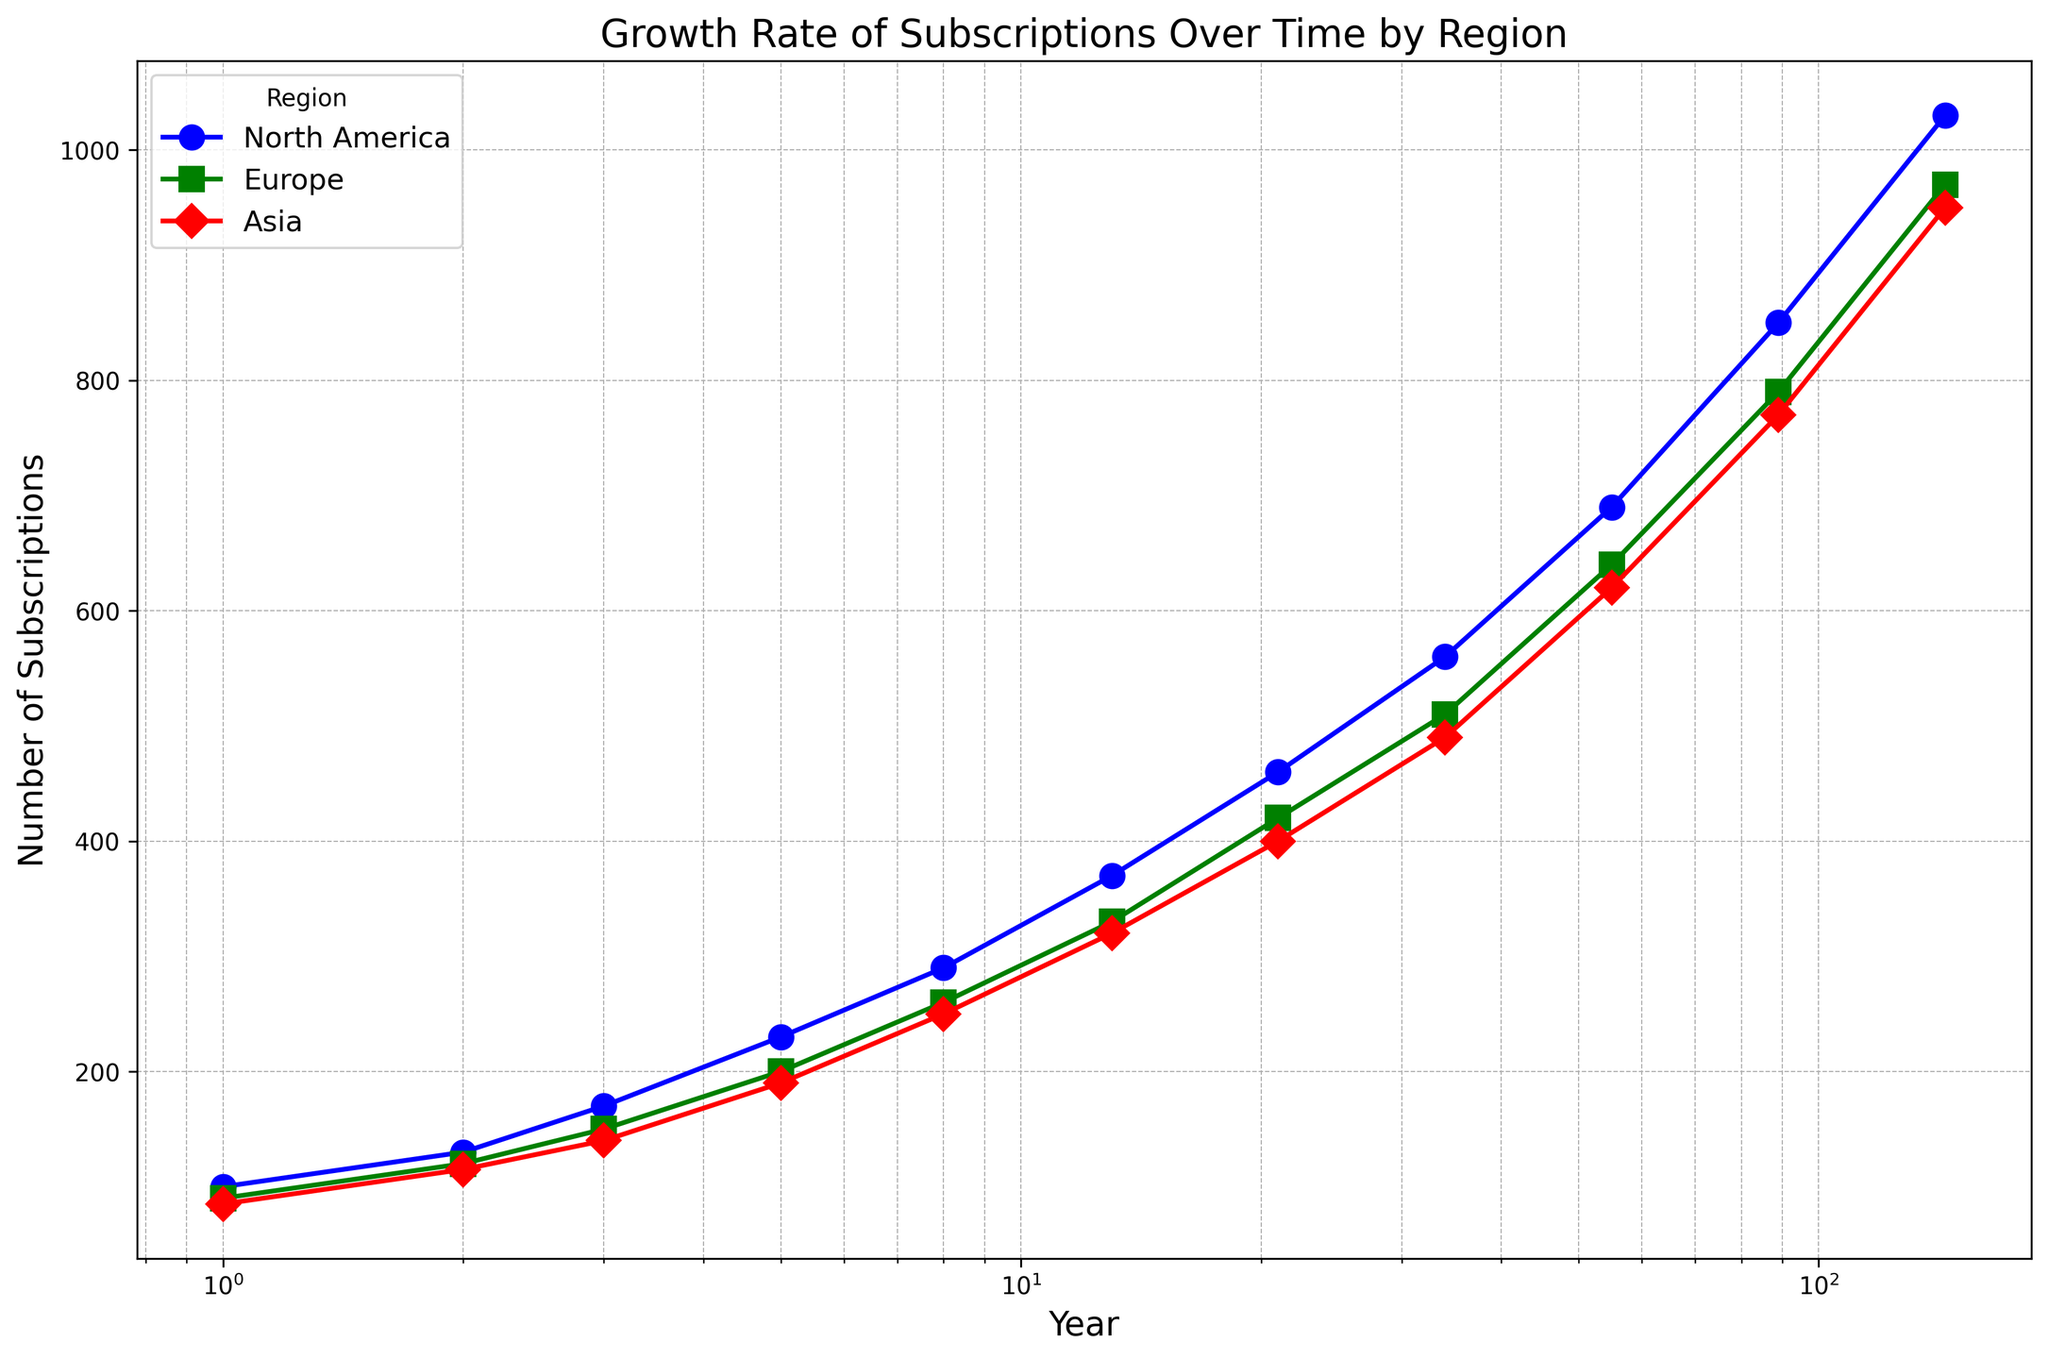What is the total number of subscriptions in the year 144 across all regions? To find the total number of subscriptions in the year 144 across all regions, sum the subscriptions from North America (1030), Europe (970), and Asia (950). 1030 + 970 + 950 = 2950
Answer: 2950 